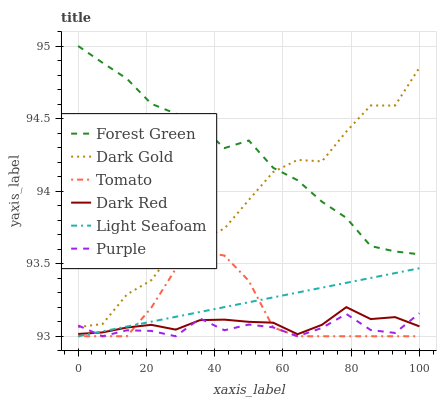Does Purple have the minimum area under the curve?
Answer yes or no. Yes. Does Forest Green have the maximum area under the curve?
Answer yes or no. Yes. Does Dark Gold have the minimum area under the curve?
Answer yes or no. No. Does Dark Gold have the maximum area under the curve?
Answer yes or no. No. Is Light Seafoam the smoothest?
Answer yes or no. Yes. Is Dark Gold the roughest?
Answer yes or no. Yes. Is Purple the smoothest?
Answer yes or no. No. Is Purple the roughest?
Answer yes or no. No. Does Dark Gold have the lowest value?
Answer yes or no. No. Does Forest Green have the highest value?
Answer yes or no. Yes. Does Dark Gold have the highest value?
Answer yes or no. No. Is Tomato less than Dark Gold?
Answer yes or no. Yes. Is Forest Green greater than Tomato?
Answer yes or no. Yes. Does Forest Green intersect Dark Gold?
Answer yes or no. Yes. Is Forest Green less than Dark Gold?
Answer yes or no. No. Is Forest Green greater than Dark Gold?
Answer yes or no. No. Does Tomato intersect Dark Gold?
Answer yes or no. No. 